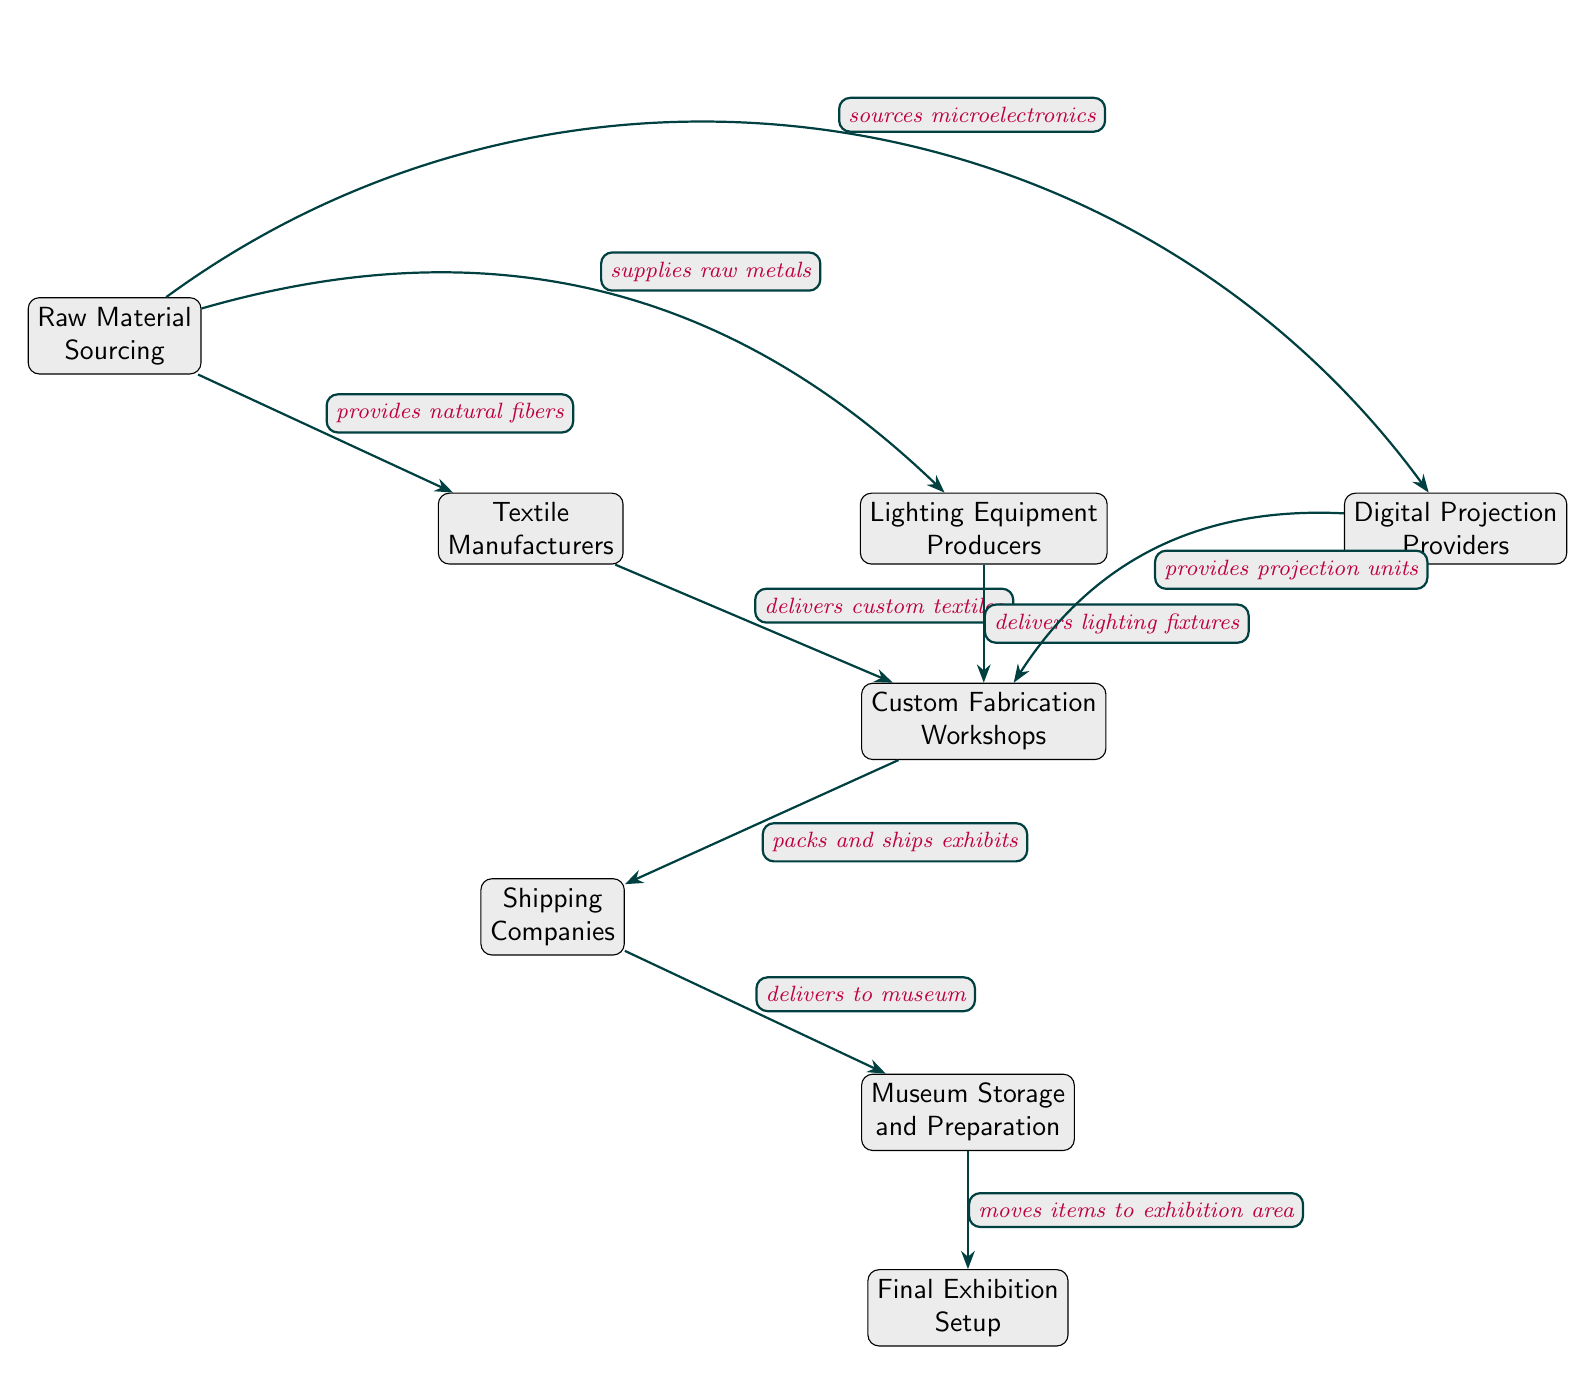What is the first node in the diagram? The first node listed in the diagram is "Raw Material Sourcing," which is the starting point for the food chain.
Answer: Raw Material Sourcing How many nodes are in the diagram? By counting all listed nodes in the diagram, we see there are a total of eight nodes connected in the flow of production and delivery cycles.
Answer: 8 What does "Textile Manufacturers" deliver? The diagram shows that "Textile Manufacturers" delivers "custom textiles" to the next node, which is "Custom Fabrication Workshops."
Answer: custom textiles Which node provides "lighting fixtures"? The "Lighting Equipment Producers" node provides "lighting fixtures" as indicated by the edge connecting it to "Custom Fabrication Workshops."
Answer: Lighting Equipment Producers What relationship exists between "Raw Material Sourcing" and "Digital Projection Providers"? The relationship is that "Raw Material Sourcing" sources microelectronics, which are essential for the operation of "Digital Projection Providers."
Answer: sources microelectronics How does "Shipping Companies" connect to the museum? "Shipping Companies" delivers items to "Museum Storage and Preparation," indicating their role in transporting materials for setup.
Answer: delivers to museum What is the last node in the sequence? The last node in the diagram is "Final Exhibition Setup," which signifies the completion of the process detailed in the food chain.
Answer: Final Exhibition Setup What happens after "Custom Fabrication Workshops"? After "Custom Fabrication Workshops," the next step is packing and shipping the exhibits, handled by "Shipping Companies."
Answer: packs and ships exhibits Which nodes are directly connected to "Custom Fabrication Workshops"? The nodes connected to "Custom Fabrication Workshops" are "Textile Manufacturers," "Lighting Equipment Producers," and "Digital Projection Providers," all leading to this workshop node.
Answer: Textile Manufacturers, Lighting Equipment Producers, Digital Projection Providers 